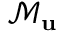<formula> <loc_0><loc_0><loc_500><loc_500>\mathcal { M } _ { u }</formula> 